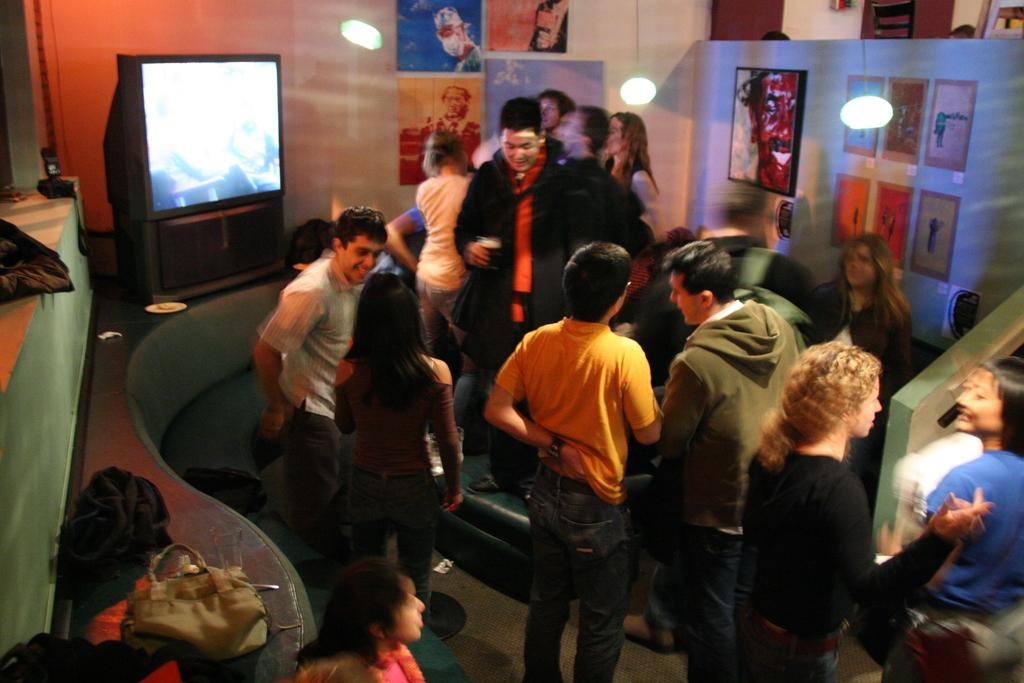What types of people are present in the image? There are men and women in the image. Where are the people located? The people are standing in a room. What are the people doing in the image? The people are engaged in a discussion. What can be seen in the background of the image? There is a television in the background of the image. What decorations are on the wall in the room? There are drawing posters on the wall. What type of lighting is present in the room? There are hanging lights in the room. What type of paste is being used by the people in the image? There is no paste visible or mentioned in the image; the people are engaged in a discussion. 